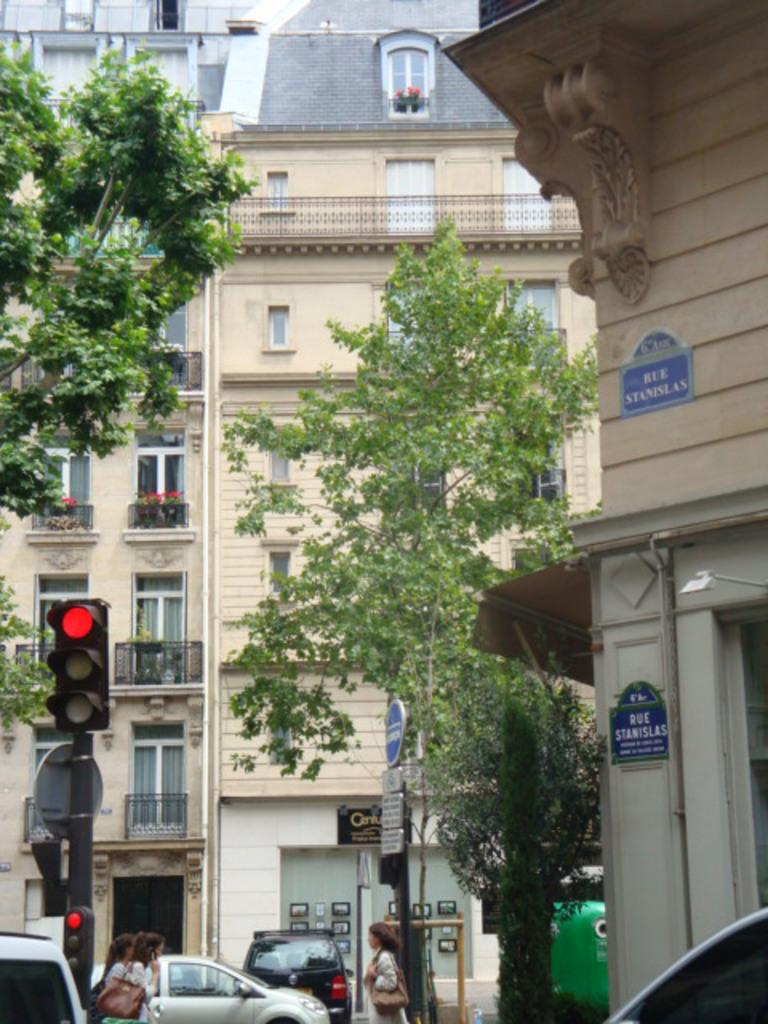What type of structures can be seen in the image? There are buildings in the image. What other natural elements are present in the image? There are trees in the image. Are there any indicators of direction or information in the image? Yes, there are sign boards in the image. What helps regulate traffic in the image? There are traffic lights in the image. What type of vehicles can be seen at the bottom of the image? Cars are visible at the bottom of the image. Are there any living beings present in the image? Yes, there are people in the image. What type of vegetable is being used as a prop by the people in the image? There is no vegetable present in the image; it features buildings, trees, sign boards, traffic lights, cars, and people. 